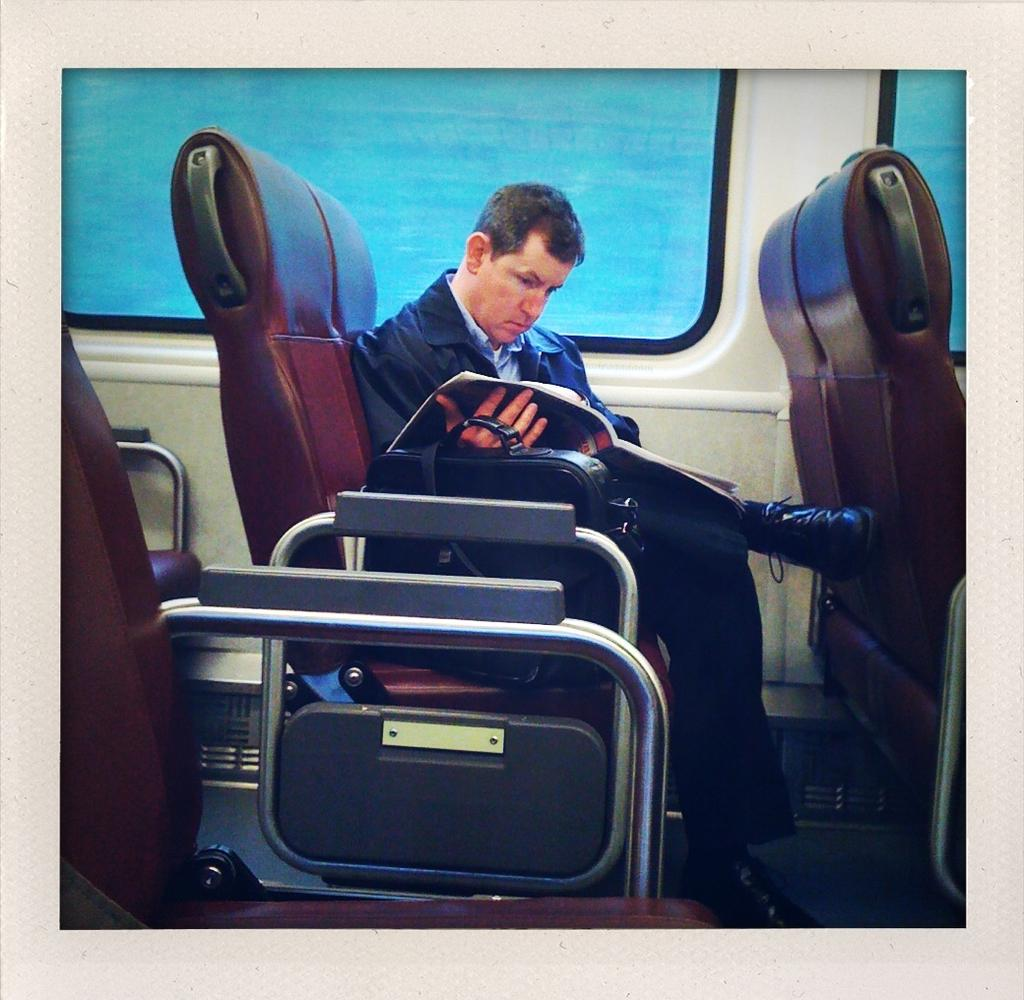What is the man in the image doing? The man is sitting on a chair in the image. What is the man holding in the image? The man is holding a book. What object is beside the man? There is a bag beside the man. What can be seen in the background of the image? There is a window in the background of the image. How many chairs are visible in the image? There are chairs around the man in the background of the image. What type of songs can be heard playing in the background of the image? There is no indication of any songs playing in the background of the image. 